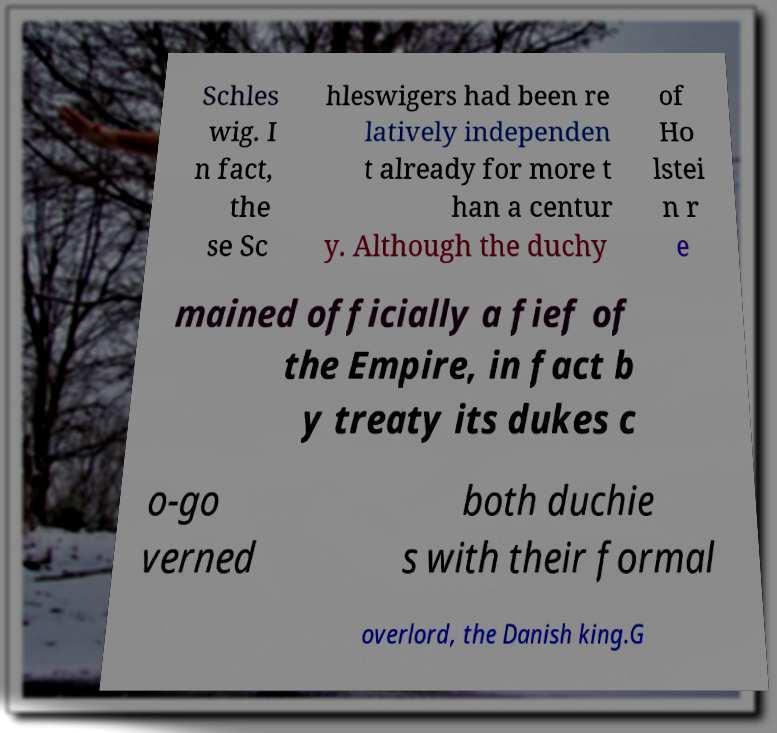There's text embedded in this image that I need extracted. Can you transcribe it verbatim? Schles wig. I n fact, the se Sc hleswigers had been re latively independen t already for more t han a centur y. Although the duchy of Ho lstei n r e mained officially a fief of the Empire, in fact b y treaty its dukes c o-go verned both duchie s with their formal overlord, the Danish king.G 